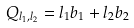<formula> <loc_0><loc_0><loc_500><loc_500>Q _ { l _ { 1 } , l _ { 2 } } = l _ { 1 } b _ { 1 } + l _ { 2 } b _ { 2 }</formula> 